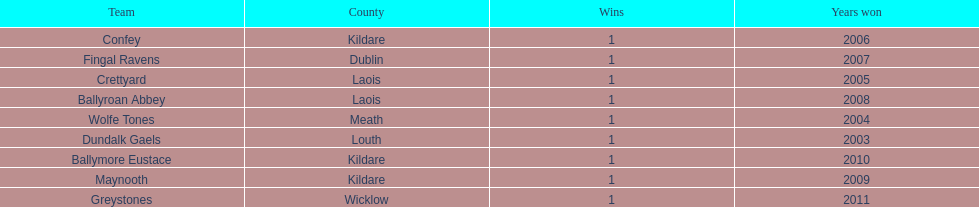Which is the first team from the chart Greystones. 